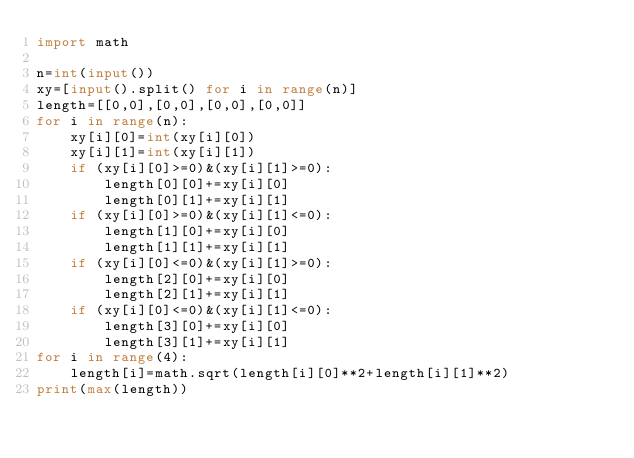<code> <loc_0><loc_0><loc_500><loc_500><_Python_>import math

n=int(input())
xy=[input().split() for i in range(n)]
length=[[0,0],[0,0],[0,0],[0,0]]
for i in range(n):
    xy[i][0]=int(xy[i][0])
    xy[i][1]=int(xy[i][1])
    if (xy[i][0]>=0)&(xy[i][1]>=0):
        length[0][0]+=xy[i][0]
        length[0][1]+=xy[i][1]
    if (xy[i][0]>=0)&(xy[i][1]<=0):
        length[1][0]+=xy[i][0]
        length[1][1]+=xy[i][1]
    if (xy[i][0]<=0)&(xy[i][1]>=0):
        length[2][0]+=xy[i][0]
        length[2][1]+=xy[i][1]
    if (xy[i][0]<=0)&(xy[i][1]<=0):
        length[3][0]+=xy[i][0]
        length[3][1]+=xy[i][1]
for i in range(4):
    length[i]=math.sqrt(length[i][0]**2+length[i][1]**2)
print(max(length))</code> 